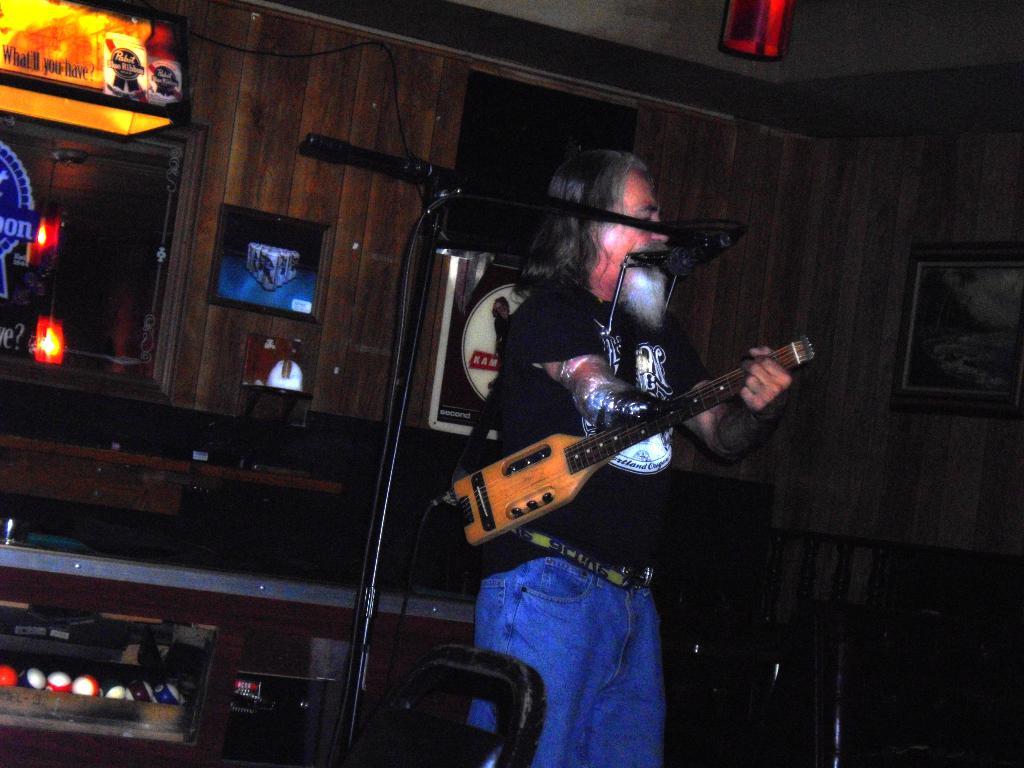What is the slogan on the pool bar lamp?
Offer a terse response. What'll you have. 